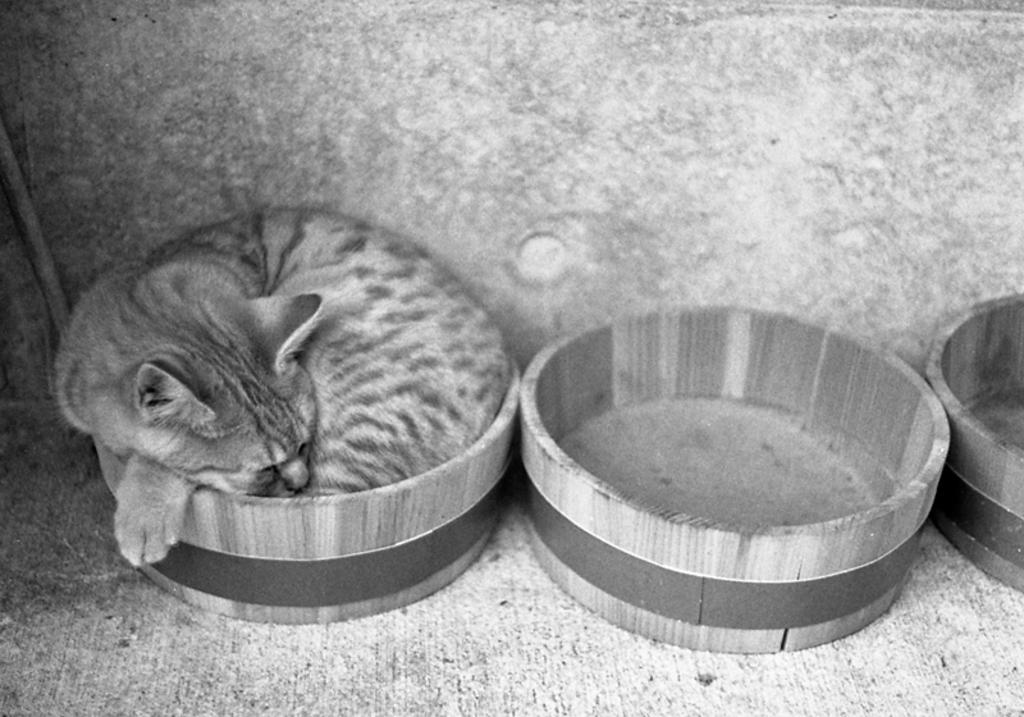What is the color scheme of the image? The image is black and white. What type of objects can be seen in the image? There are wooden objects in the image. Can you describe the presence of a cat in the image? A cat is inside one of the wooden objects. What is visible in the background of the image? There is a wall in the background of the image. What type of cork can be seen floating in the basin in the image? There is no basin or cork present in the image. How much milk is being poured into the cat's bowl in the image? There is no milk or cat's bowl present in the image. 